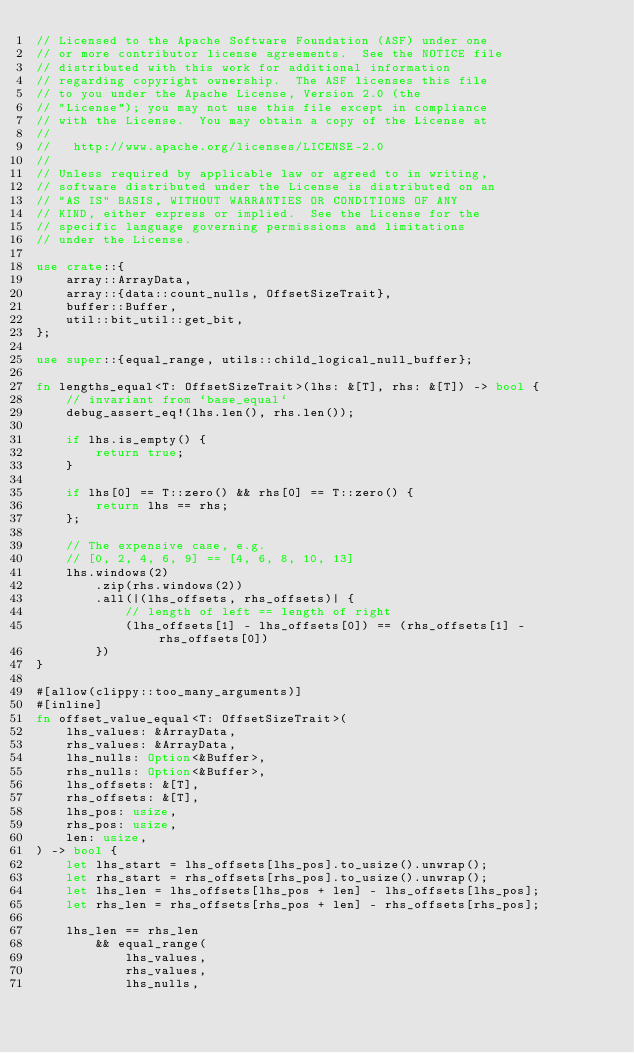<code> <loc_0><loc_0><loc_500><loc_500><_Rust_>// Licensed to the Apache Software Foundation (ASF) under one
// or more contributor license agreements.  See the NOTICE file
// distributed with this work for additional information
// regarding copyright ownership.  The ASF licenses this file
// to you under the Apache License, Version 2.0 (the
// "License"); you may not use this file except in compliance
// with the License.  You may obtain a copy of the License at
//
//   http://www.apache.org/licenses/LICENSE-2.0
//
// Unless required by applicable law or agreed to in writing,
// software distributed under the License is distributed on an
// "AS IS" BASIS, WITHOUT WARRANTIES OR CONDITIONS OF ANY
// KIND, either express or implied.  See the License for the
// specific language governing permissions and limitations
// under the License.

use crate::{
    array::ArrayData,
    array::{data::count_nulls, OffsetSizeTrait},
    buffer::Buffer,
    util::bit_util::get_bit,
};

use super::{equal_range, utils::child_logical_null_buffer};

fn lengths_equal<T: OffsetSizeTrait>(lhs: &[T], rhs: &[T]) -> bool {
    // invariant from `base_equal`
    debug_assert_eq!(lhs.len(), rhs.len());

    if lhs.is_empty() {
        return true;
    }

    if lhs[0] == T::zero() && rhs[0] == T::zero() {
        return lhs == rhs;
    };

    // The expensive case, e.g.
    // [0, 2, 4, 6, 9] == [4, 6, 8, 10, 13]
    lhs.windows(2)
        .zip(rhs.windows(2))
        .all(|(lhs_offsets, rhs_offsets)| {
            // length of left == length of right
            (lhs_offsets[1] - lhs_offsets[0]) == (rhs_offsets[1] - rhs_offsets[0])
        })
}

#[allow(clippy::too_many_arguments)]
#[inline]
fn offset_value_equal<T: OffsetSizeTrait>(
    lhs_values: &ArrayData,
    rhs_values: &ArrayData,
    lhs_nulls: Option<&Buffer>,
    rhs_nulls: Option<&Buffer>,
    lhs_offsets: &[T],
    rhs_offsets: &[T],
    lhs_pos: usize,
    rhs_pos: usize,
    len: usize,
) -> bool {
    let lhs_start = lhs_offsets[lhs_pos].to_usize().unwrap();
    let rhs_start = rhs_offsets[rhs_pos].to_usize().unwrap();
    let lhs_len = lhs_offsets[lhs_pos + len] - lhs_offsets[lhs_pos];
    let rhs_len = rhs_offsets[rhs_pos + len] - rhs_offsets[rhs_pos];

    lhs_len == rhs_len
        && equal_range(
            lhs_values,
            rhs_values,
            lhs_nulls,</code> 